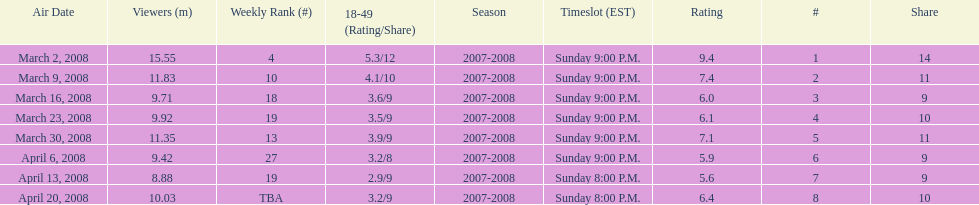Would you be able to parse every entry in this table? {'header': ['Air Date', 'Viewers (m)', 'Weekly Rank (#)', '18-49 (Rating/Share)', 'Season', 'Timeslot (EST)', 'Rating', '#', 'Share'], 'rows': [['March 2, 2008', '15.55', '4', '5.3/12', '2007-2008', 'Sunday 9:00 P.M.', '9.4', '1', '14'], ['March 9, 2008', '11.83', '10', '4.1/10', '2007-2008', 'Sunday 9:00 P.M.', '7.4', '2', '11'], ['March 16, 2008', '9.71', '18', '3.6/9', '2007-2008', 'Sunday 9:00 P.M.', '6.0', '3', '9'], ['March 23, 2008', '9.92', '19', '3.5/9', '2007-2008', 'Sunday 9:00 P.M.', '6.1', '4', '10'], ['March 30, 2008', '11.35', '13', '3.9/9', '2007-2008', 'Sunday 9:00 P.M.', '7.1', '5', '11'], ['April 6, 2008', '9.42', '27', '3.2/8', '2007-2008', 'Sunday 9:00 P.M.', '5.9', '6', '9'], ['April 13, 2008', '8.88', '19', '2.9/9', '2007-2008', 'Sunday 8:00 P.M.', '5.6', '7', '9'], ['April 20, 2008', '10.03', 'TBA', '3.2/9', '2007-2008', 'Sunday 8:00 P.M.', '6.4', '8', '10']]} How many shows had more than 10 million viewers? 4. 